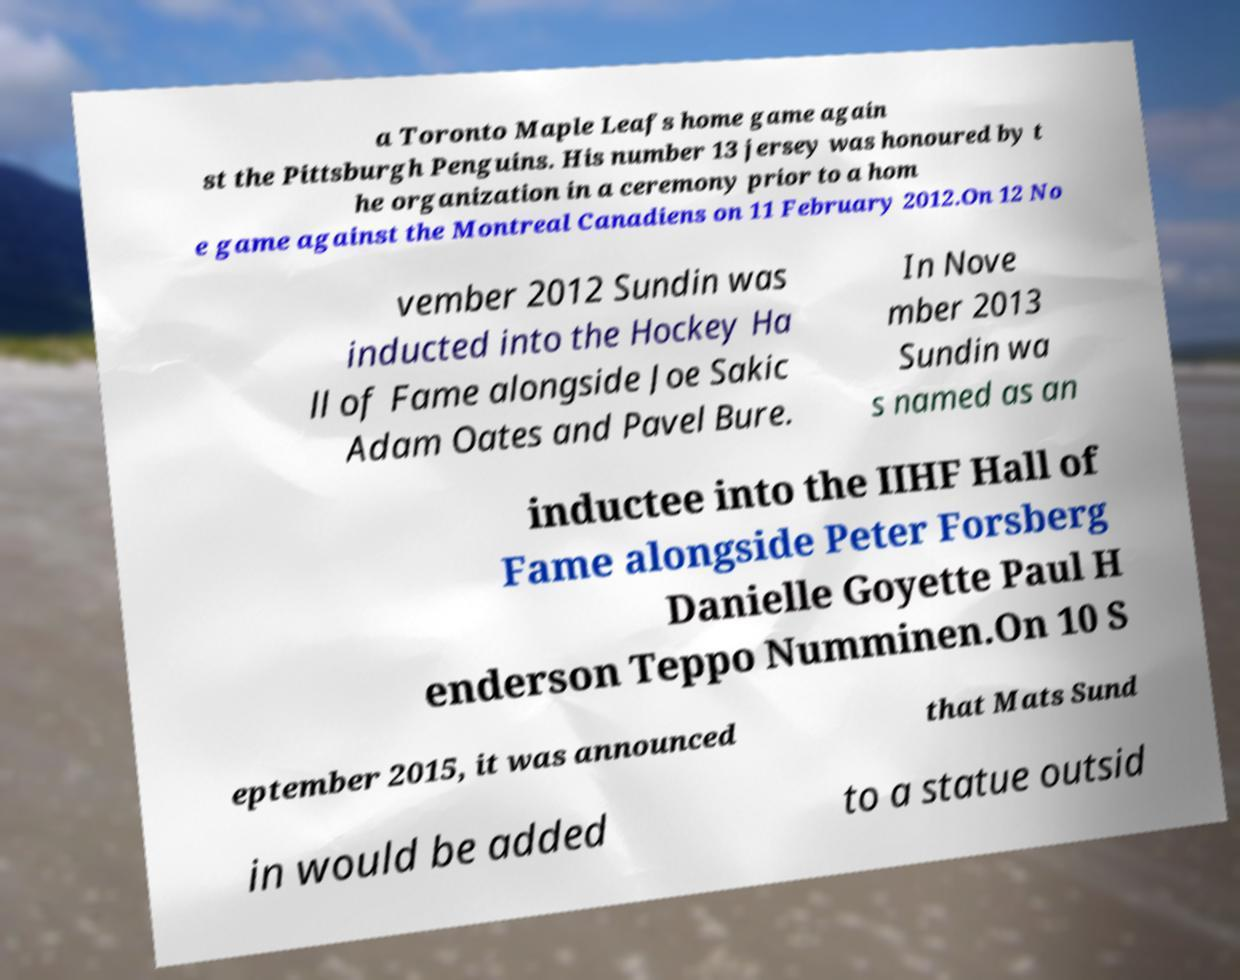Could you assist in decoding the text presented in this image and type it out clearly? a Toronto Maple Leafs home game again st the Pittsburgh Penguins. His number 13 jersey was honoured by t he organization in a ceremony prior to a hom e game against the Montreal Canadiens on 11 February 2012.On 12 No vember 2012 Sundin was inducted into the Hockey Ha ll of Fame alongside Joe Sakic Adam Oates and Pavel Bure. In Nove mber 2013 Sundin wa s named as an inductee into the IIHF Hall of Fame alongside Peter Forsberg Danielle Goyette Paul H enderson Teppo Numminen.On 10 S eptember 2015, it was announced that Mats Sund in would be added to a statue outsid 